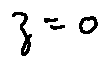Convert formula to latex. <formula><loc_0><loc_0><loc_500><loc_500>z = 0</formula> 